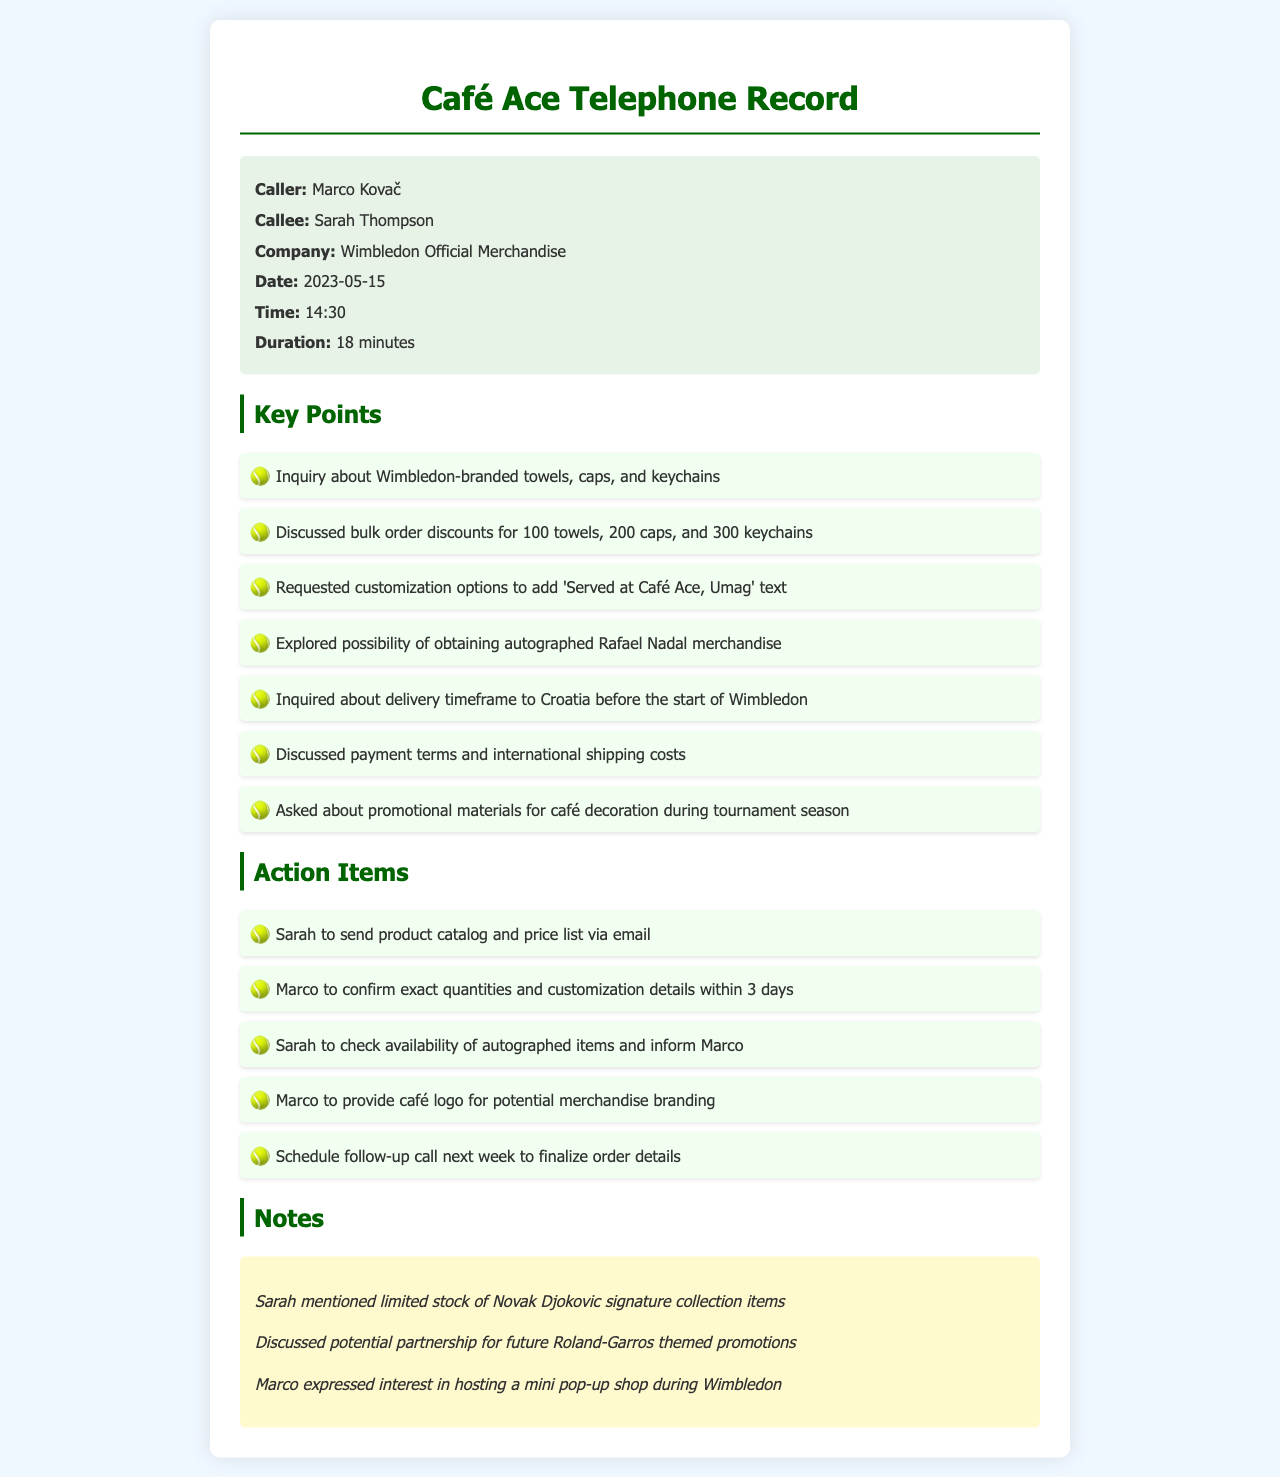What date was the call made? The date of the call, as mentioned in the document, is 2023-05-15.
Answer: 2023-05-15 Who is the caller? The caller's name is provided in the document as Marco Kovač.
Answer: Marco Kovač What company did Sarah Thompson represent? The document indicates that Sarah Thompson is representing Wimbledon Official Merchandise.
Answer: Wimbledon Official Merchandise How long did the call last? The duration of the call stated in the document is 18 minutes.
Answer: 18 minutes What item was discussed in bulk orders? The key points mention bulk order discounts for towels, caps, and keychains.
Answer: Towels, caps, keychains What customization was requested for the towels? It is stated in the document that Marco requested to add 'Served at Café Ace, Umag' text on the merchandise.
Answer: 'Served at Café Ace, Umag' What is scheduled for next week? The document mentions a follow-up call is to be scheduled next week to finalize order details.
Answer: Follow-up call What special items did Marco express interest in? The notes indicate that Marco is interested in obtaining autographed Rafael Nadal merchandise.
Answer: Autographed Rafael Nadal merchandise What promotion type was discussed for future collaboration? The notes mention a potential partnership for future Roland-Garros themed promotions.
Answer: Roland-Garros themed promotions 